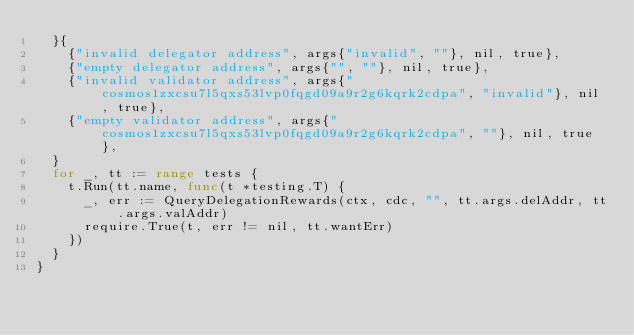Convert code to text. <code><loc_0><loc_0><loc_500><loc_500><_Go_>	}{
		{"invalid delegator address", args{"invalid", ""}, nil, true},
		{"empty delegator address", args{"", ""}, nil, true},
		{"invalid validator address", args{"cosmos1zxcsu7l5qxs53lvp0fqgd09a9r2g6kqrk2cdpa", "invalid"}, nil, true},
		{"empty validator address", args{"cosmos1zxcsu7l5qxs53lvp0fqgd09a9r2g6kqrk2cdpa", ""}, nil, true},
	}
	for _, tt := range tests {
		t.Run(tt.name, func(t *testing.T) {
			_, err := QueryDelegationRewards(ctx, cdc, "", tt.args.delAddr, tt.args.valAddr)
			require.True(t, err != nil, tt.wantErr)
		})
	}
}
</code> 